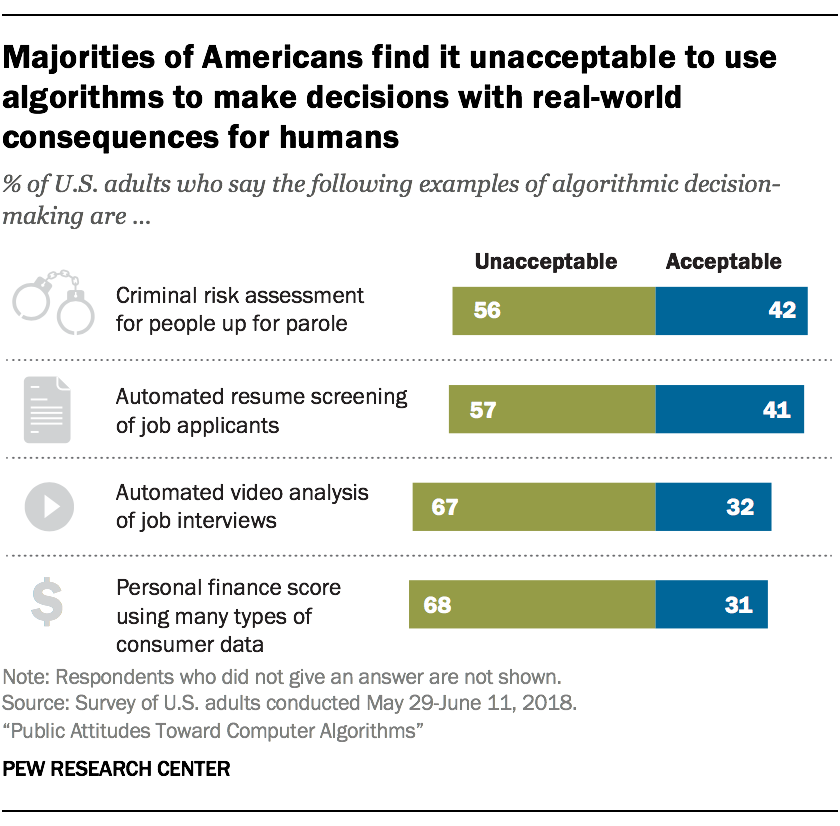Specify some key components in this picture. The average height of green bars is equal to twice the smallest height of blue bars. The value of the leftmost upper bar is 56. 